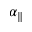<formula> <loc_0><loc_0><loc_500><loc_500>\alpha _ { \| }</formula> 